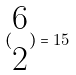<formula> <loc_0><loc_0><loc_500><loc_500>( \begin{matrix} 6 \\ 2 \end{matrix} ) = 1 5</formula> 